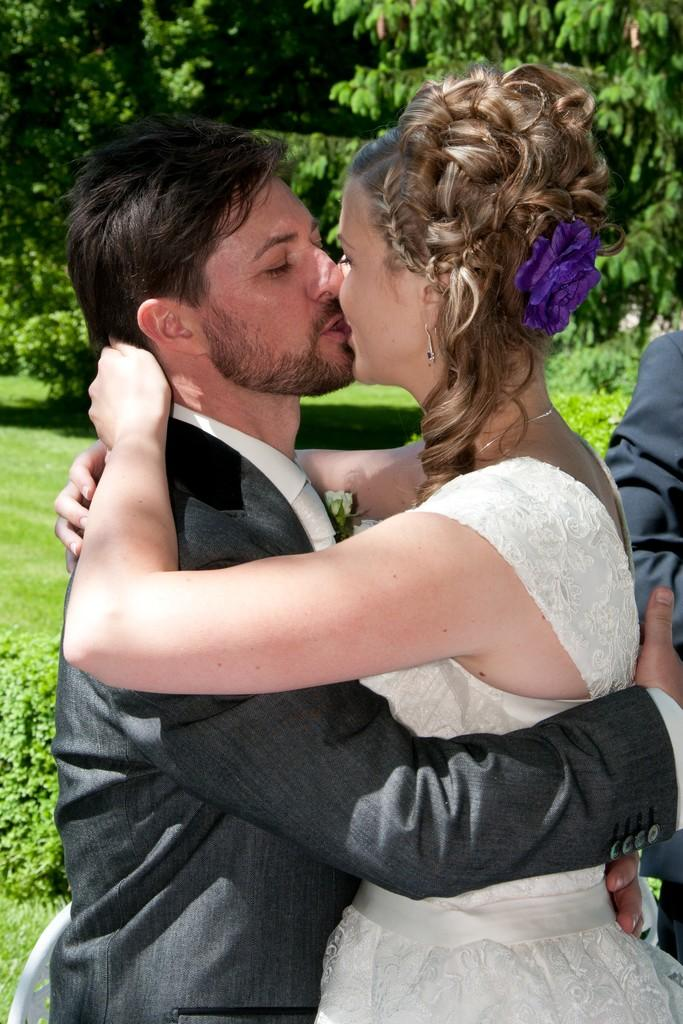What can be observed about the people in the image? There are people with different color dresses in the image. What is visible in the background of the image? There are plants and many trees in the background of the image. Can you tell me how many snails are crawling on the people's dresses in the image? There are no snails visible on the people's dresses in the image. What type of drink is being served at the event in the image? The image does not show any drinks or events, so it cannot be determined what type of drink might be served. 